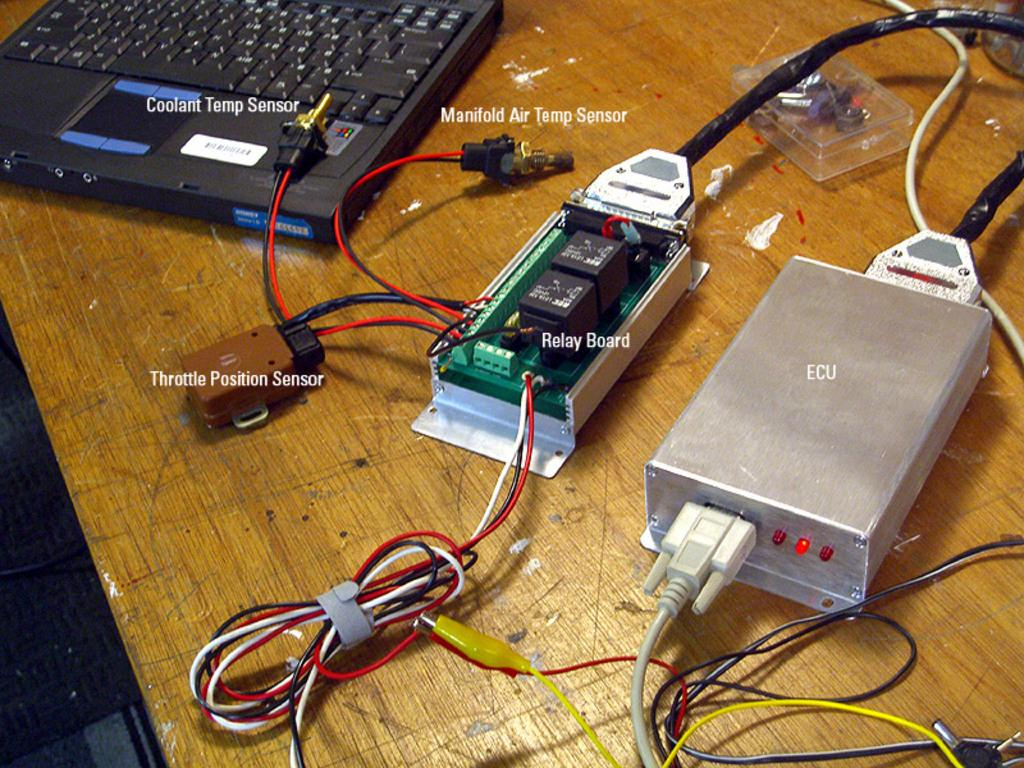What electronic device is visible in the image? There is a laptop in the image. What type of material is present in the image? There is a chipboard in the image. What is used to connect devices in the image? There is a connector in the image. What are used to transmit data or power in the image? There are cables in the image. On what surface are all these objects placed? All these objects are on a table in the image. What is the main plot of the love story unfolding in the image? There is no love story or plot present in the image; it features a laptop, chipboard, connector, and cables on a table. 